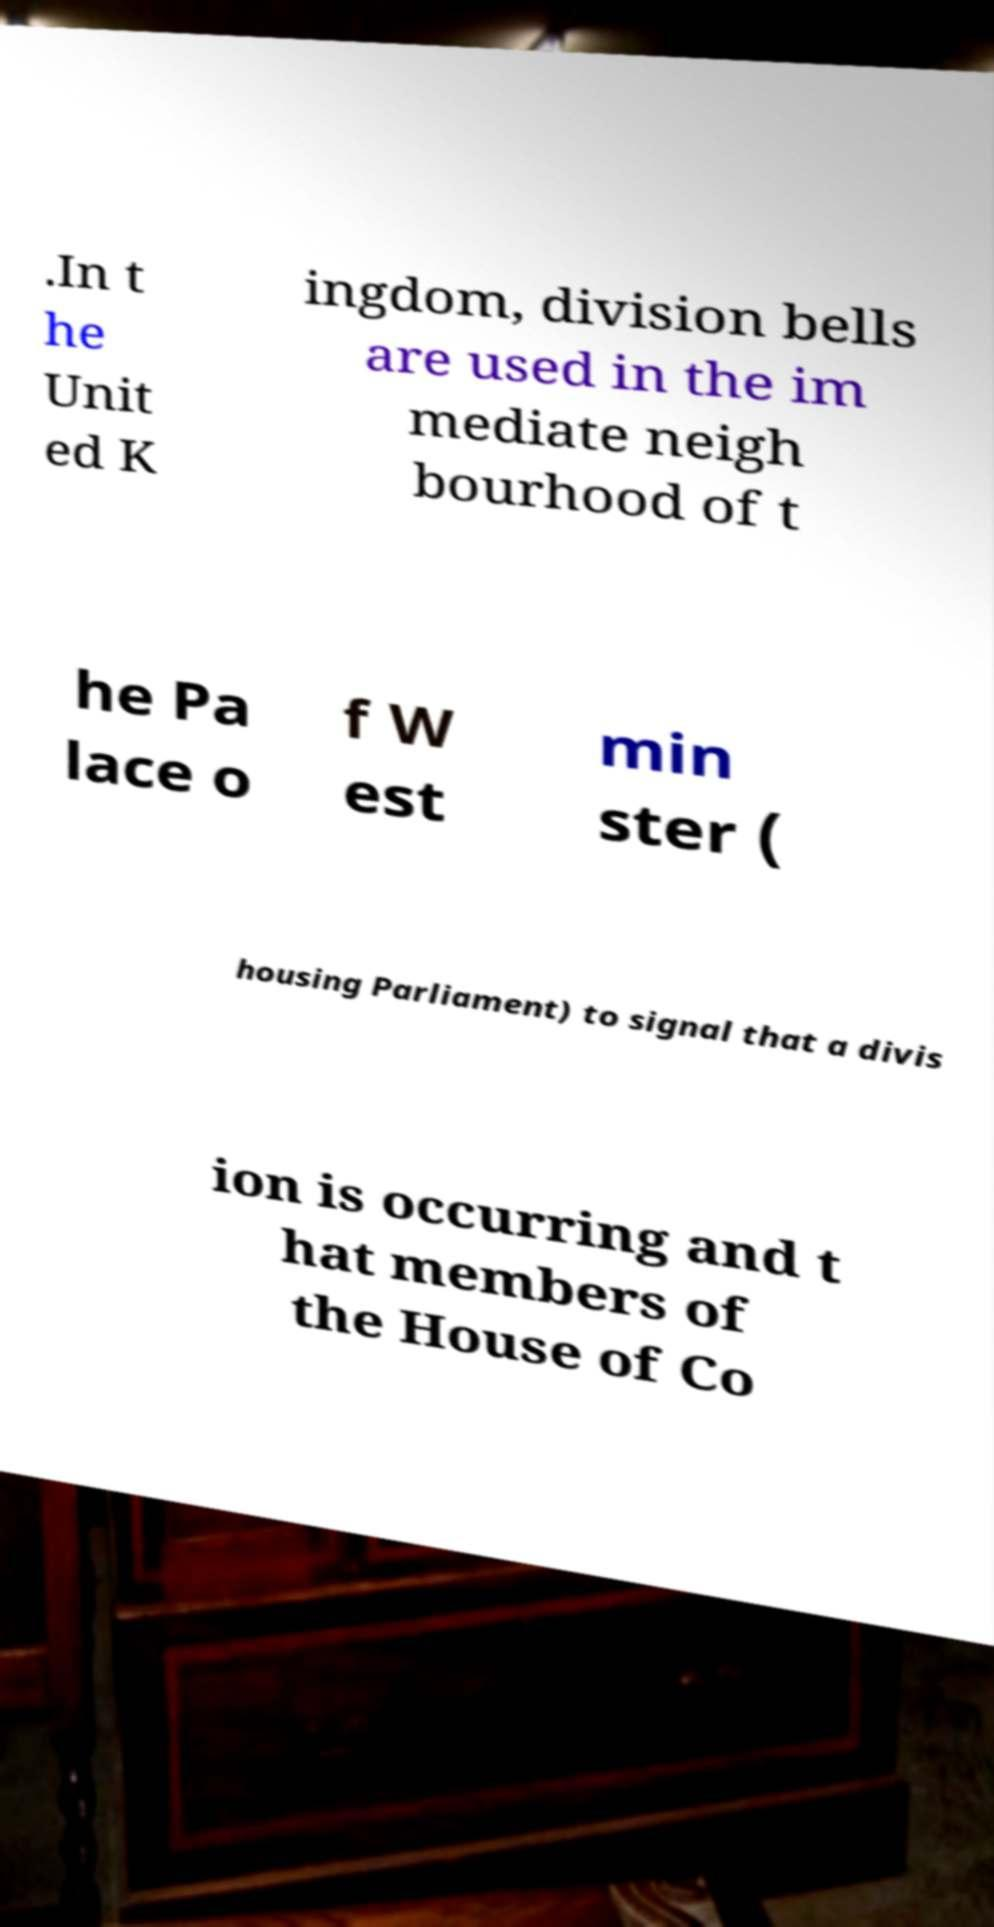I need the written content from this picture converted into text. Can you do that? .In t he Unit ed K ingdom, division bells are used in the im mediate neigh bourhood of t he Pa lace o f W est min ster ( housing Parliament) to signal that a divis ion is occurring and t hat members of the House of Co 